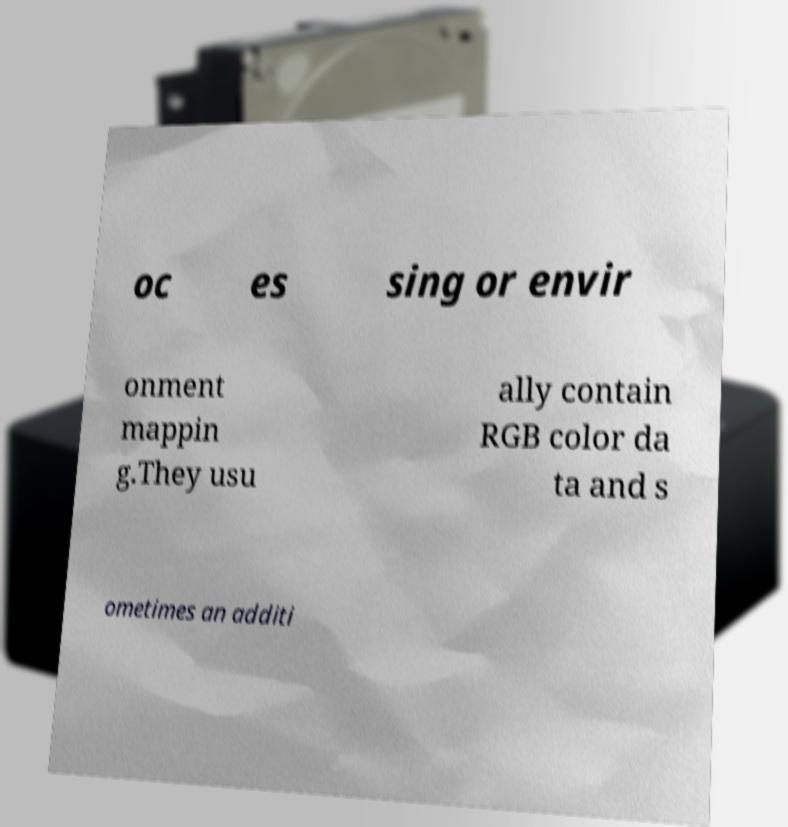Could you extract and type out the text from this image? oc es sing or envir onment mappin g.They usu ally contain RGB color da ta and s ometimes an additi 